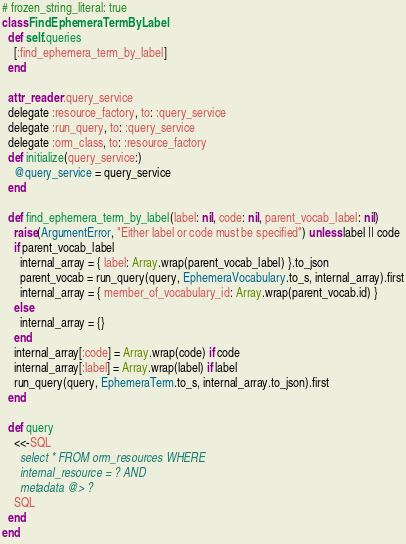Convert code to text. <code><loc_0><loc_0><loc_500><loc_500><_Ruby_># frozen_string_literal: true
class FindEphemeraTermByLabel
  def self.queries
    [:find_ephemera_term_by_label]
  end

  attr_reader :query_service
  delegate :resource_factory, to: :query_service
  delegate :run_query, to: :query_service
  delegate :orm_class, to: :resource_factory
  def initialize(query_service:)
    @query_service = query_service
  end

  def find_ephemera_term_by_label(label: nil, code: nil, parent_vocab_label: nil)
    raise(ArgumentError, "Either label or code must be specified") unless label || code
    if parent_vocab_label
      internal_array = { label: Array.wrap(parent_vocab_label) }.to_json
      parent_vocab = run_query(query, EphemeraVocabulary.to_s, internal_array).first
      internal_array = { member_of_vocabulary_id: Array.wrap(parent_vocab.id) }
    else
      internal_array = {}
    end
    internal_array[:code] = Array.wrap(code) if code
    internal_array[:label] = Array.wrap(label) if label
    run_query(query, EphemeraTerm.to_s, internal_array.to_json).first
  end

  def query
    <<-SQL
      select * FROM orm_resources WHERE
      internal_resource = ? AND
      metadata @> ?
    SQL
  end
end
</code> 